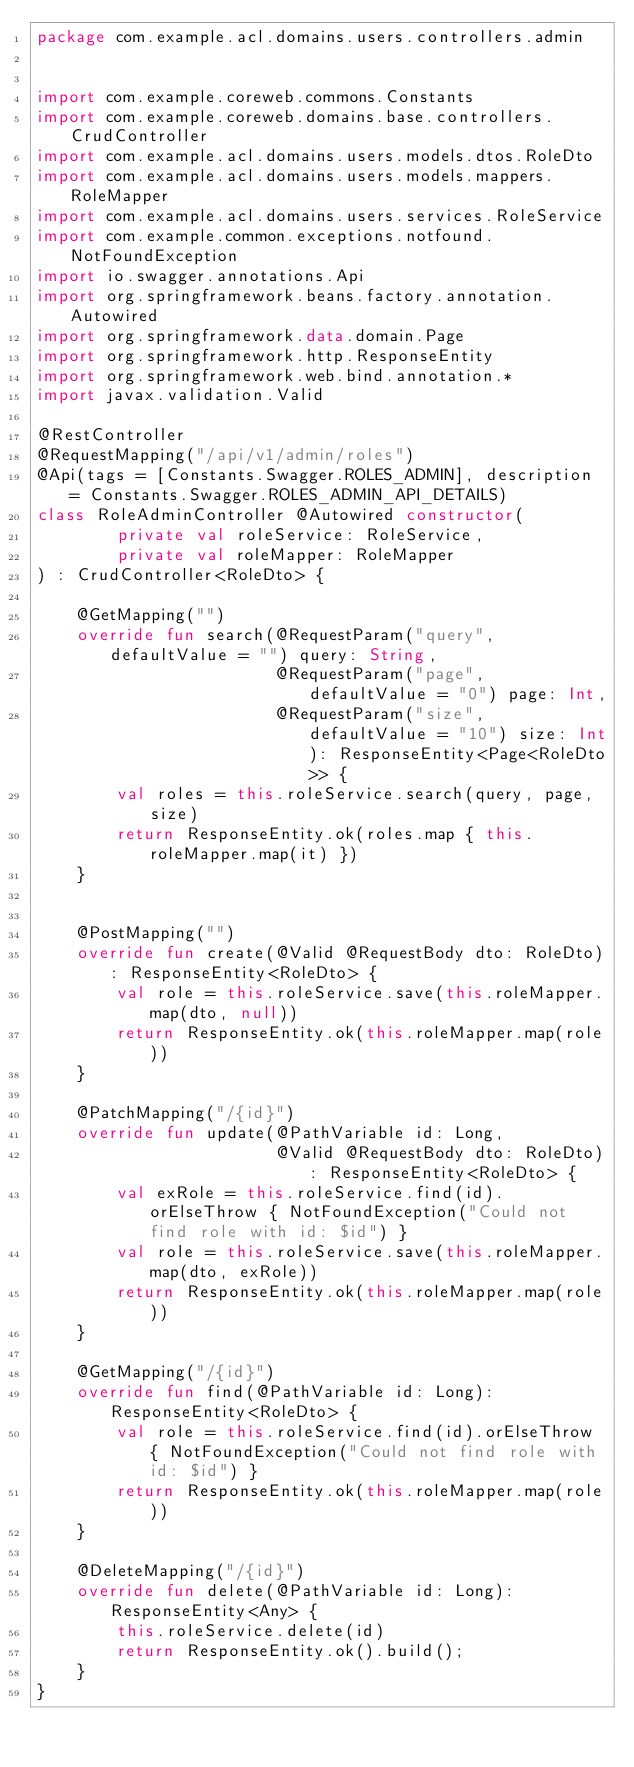Convert code to text. <code><loc_0><loc_0><loc_500><loc_500><_Kotlin_>package com.example.acl.domains.users.controllers.admin


import com.example.coreweb.commons.Constants
import com.example.coreweb.domains.base.controllers.CrudController
import com.example.acl.domains.users.models.dtos.RoleDto
import com.example.acl.domains.users.models.mappers.RoleMapper
import com.example.acl.domains.users.services.RoleService
import com.example.common.exceptions.notfound.NotFoundException
import io.swagger.annotations.Api
import org.springframework.beans.factory.annotation.Autowired
import org.springframework.data.domain.Page
import org.springframework.http.ResponseEntity
import org.springframework.web.bind.annotation.*
import javax.validation.Valid

@RestController
@RequestMapping("/api/v1/admin/roles")
@Api(tags = [Constants.Swagger.ROLES_ADMIN], description = Constants.Swagger.ROLES_ADMIN_API_DETAILS)
class RoleAdminController @Autowired constructor(
        private val roleService: RoleService,
        private val roleMapper: RoleMapper
) : CrudController<RoleDto> {

    @GetMapping("")
    override fun search(@RequestParam("query", defaultValue = "") query: String,
                        @RequestParam("page", defaultValue = "0") page: Int,
                        @RequestParam("size", defaultValue = "10") size: Int): ResponseEntity<Page<RoleDto>> {
        val roles = this.roleService.search(query, page, size)
        return ResponseEntity.ok(roles.map { this.roleMapper.map(it) })
    }


    @PostMapping("")
    override fun create(@Valid @RequestBody dto: RoleDto): ResponseEntity<RoleDto> {
        val role = this.roleService.save(this.roleMapper.map(dto, null))
        return ResponseEntity.ok(this.roleMapper.map(role))
    }

    @PatchMapping("/{id}")
    override fun update(@PathVariable id: Long,
                        @Valid @RequestBody dto: RoleDto): ResponseEntity<RoleDto> {
        val exRole = this.roleService.find(id).orElseThrow { NotFoundException("Could not find role with id: $id") }
        val role = this.roleService.save(this.roleMapper.map(dto, exRole))
        return ResponseEntity.ok(this.roleMapper.map(role))
    }

    @GetMapping("/{id}")
    override fun find(@PathVariable id: Long): ResponseEntity<RoleDto> {
        val role = this.roleService.find(id).orElseThrow { NotFoundException("Could not find role with id: $id") }
        return ResponseEntity.ok(this.roleMapper.map(role))
    }

    @DeleteMapping("/{id}")
    override fun delete(@PathVariable id: Long): ResponseEntity<Any> {
        this.roleService.delete(id)
        return ResponseEntity.ok().build();
    }
}
</code> 